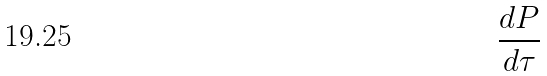Convert formula to latex. <formula><loc_0><loc_0><loc_500><loc_500>\frac { d P } { d \tau }</formula> 